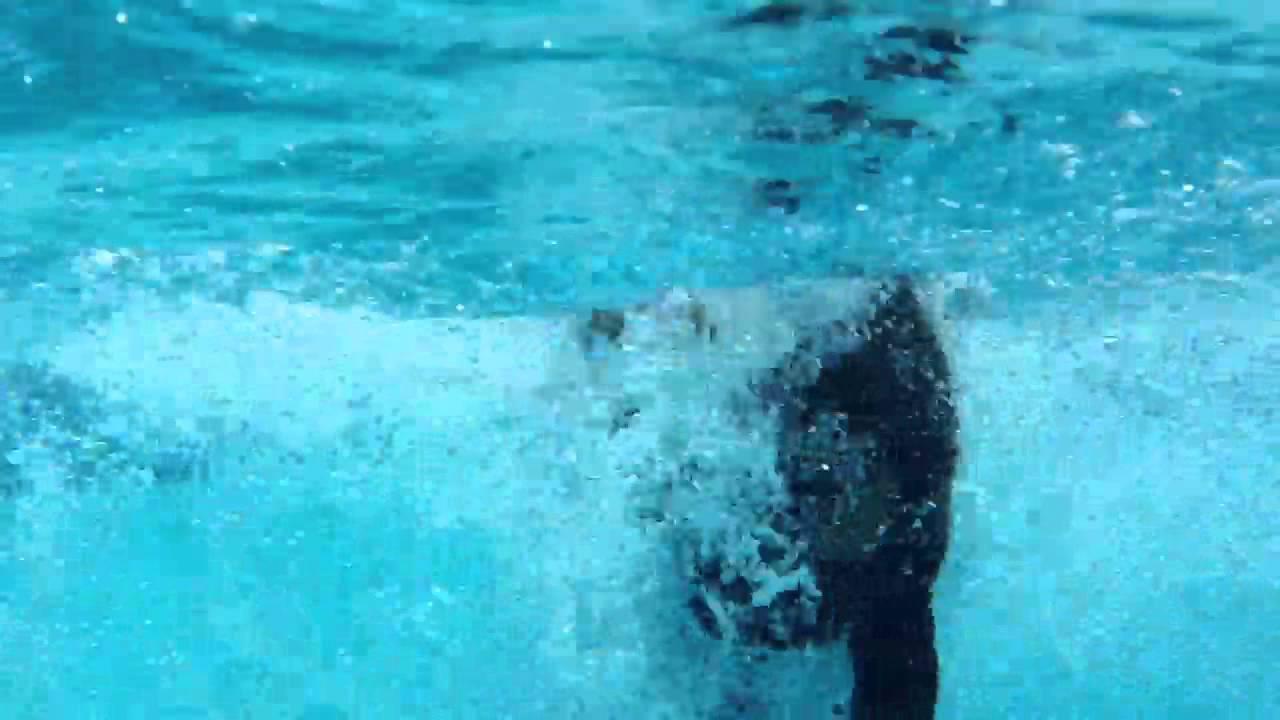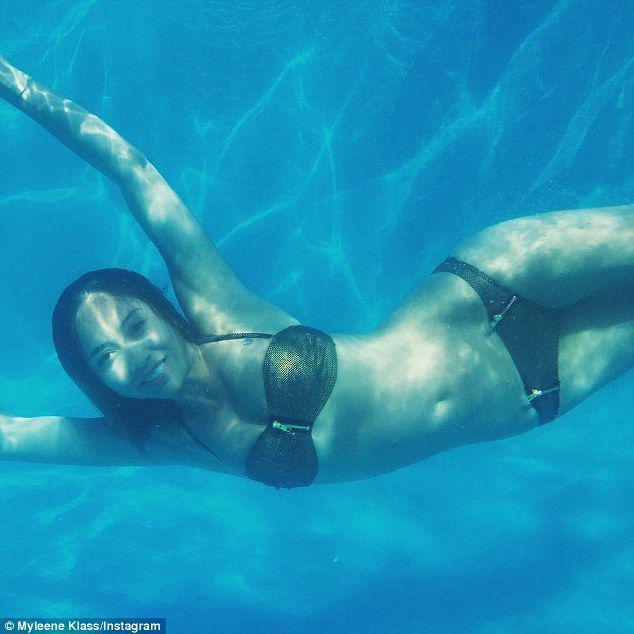The first image is the image on the left, the second image is the image on the right. For the images displayed, is the sentence "An image shows a doberman underwater with his muzzle pointed downward just above a flat object." factually correct? Answer yes or no. No. The first image is the image on the left, the second image is the image on the right. Given the left and right images, does the statement "The left and right image contains the same number of dogs with at least one dog grabbing a frisbee." hold true? Answer yes or no. No. 